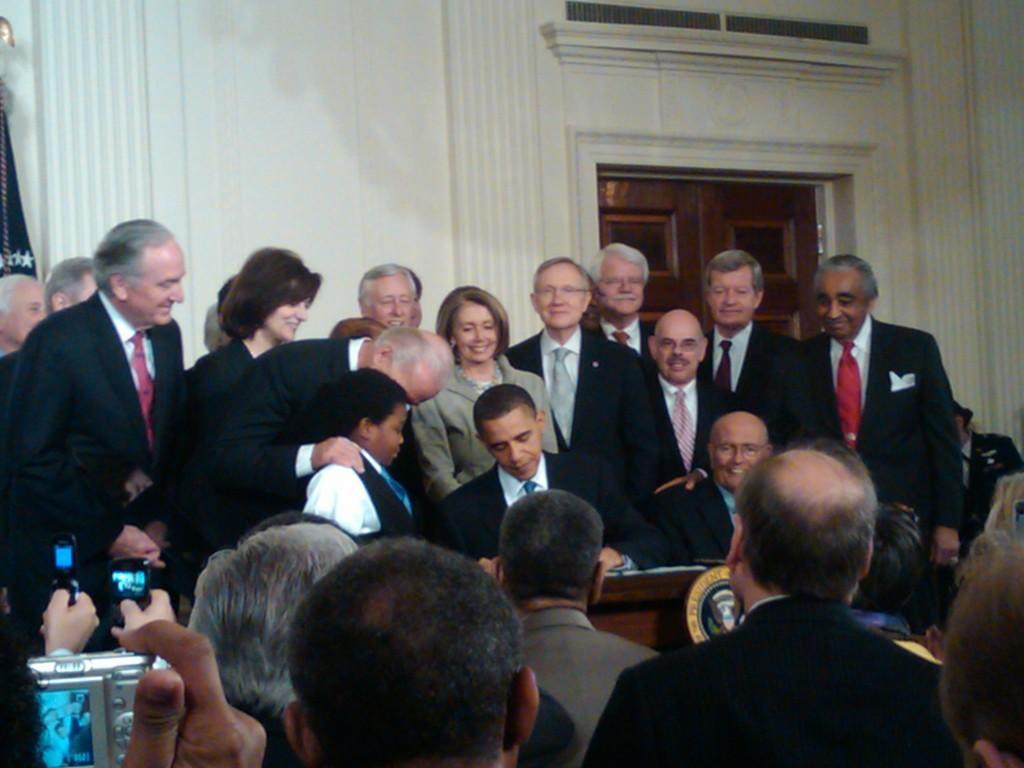Could you give a brief overview of what you see in this image? In this picture there are two persons sitting in a chair and there is a table in front of them which has few objects placed on it and there are few persons standing behind them and there are few other people sitting in the right corner and there are few people holding a camera and mobile phones in their hands in the left corner. 